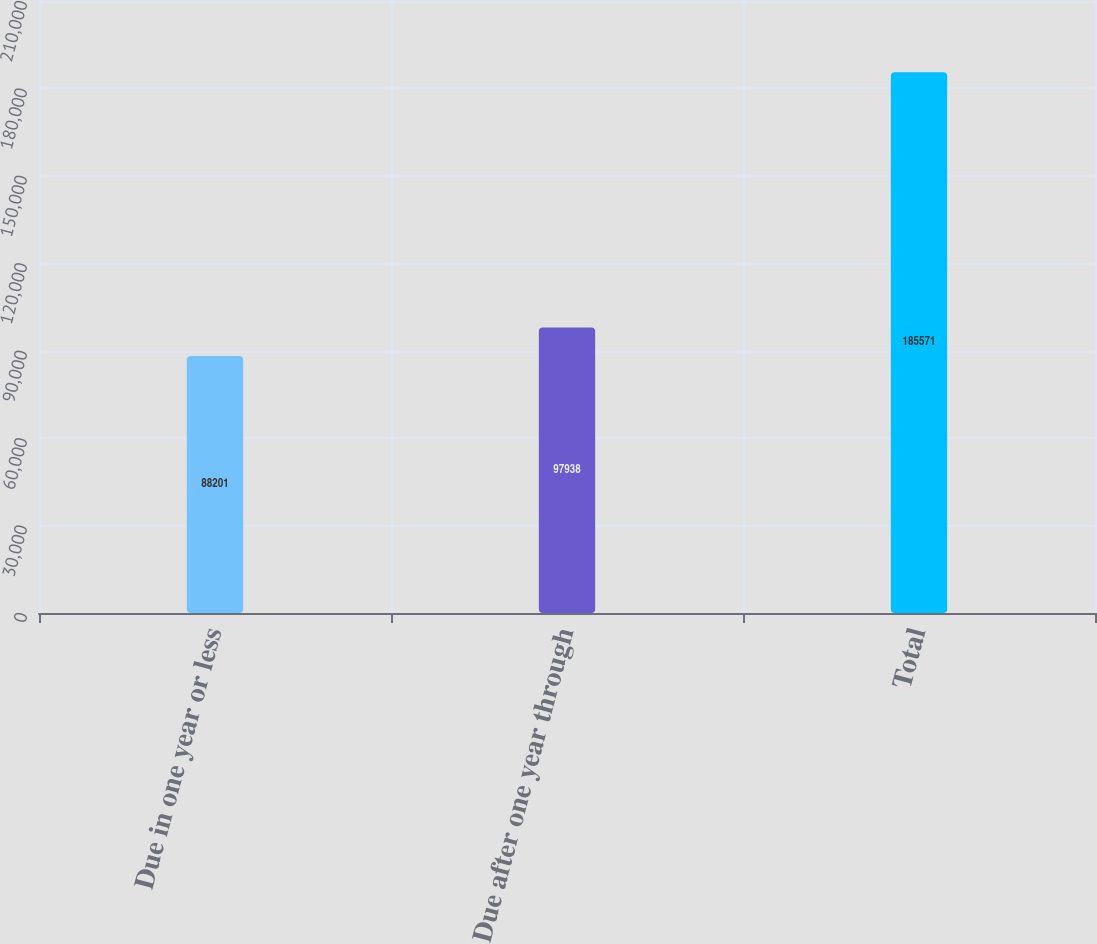Convert chart. <chart><loc_0><loc_0><loc_500><loc_500><bar_chart><fcel>Due in one year or less<fcel>Due after one year through<fcel>Total<nl><fcel>88201<fcel>97938<fcel>185571<nl></chart> 